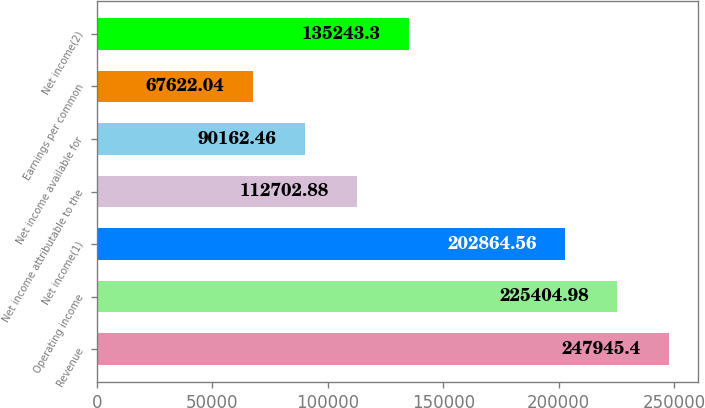<chart> <loc_0><loc_0><loc_500><loc_500><bar_chart><fcel>Revenue<fcel>Operating income<fcel>Net income(1)<fcel>Net income attributable to the<fcel>Net income available for<fcel>Earnings per common<fcel>Net income(2)<nl><fcel>247945<fcel>225405<fcel>202865<fcel>112703<fcel>90162.5<fcel>67622<fcel>135243<nl></chart> 